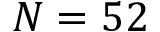<formula> <loc_0><loc_0><loc_500><loc_500>N = 5 2</formula> 